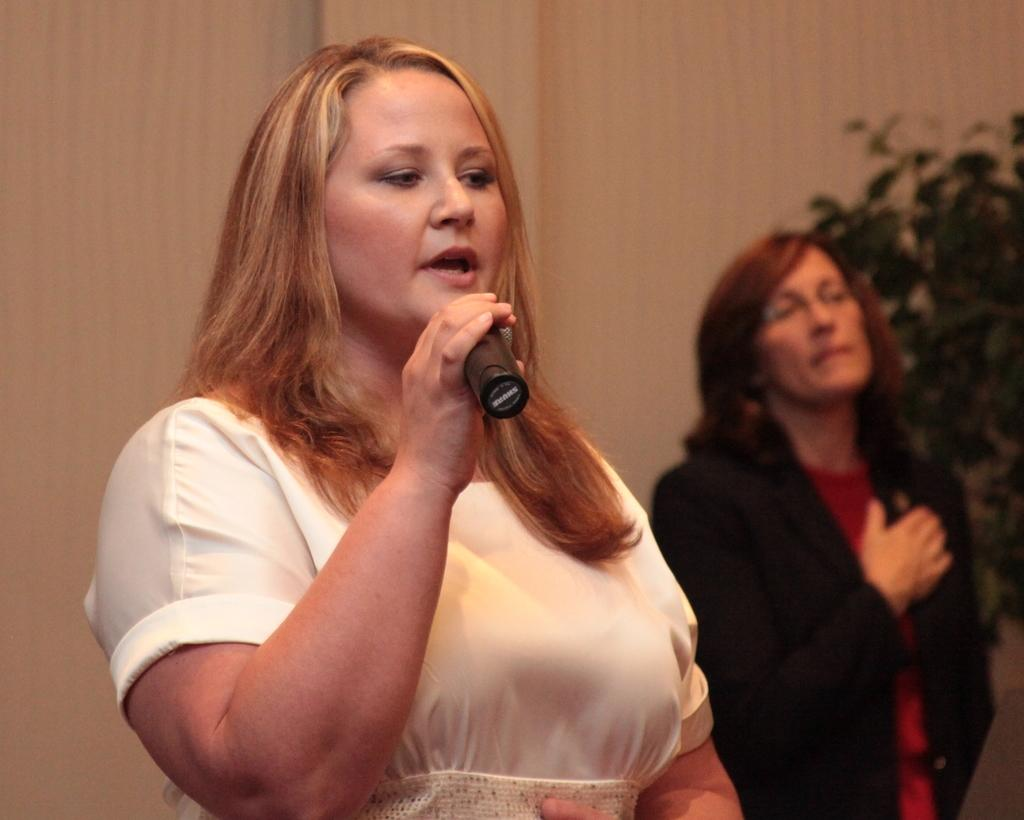What is the woman in the image holding? The woman is holding a mic in the image. What is the woman with the mic doing? The woman is talking. Can you describe the other woman in the image? There is another woman standing in the image. What type of vegetation can be seen in the image? There is a plant visible in the image. What is at the back of the scene? There is a wall at the back of the scene. What type of cream is being offered by the woman with the mic? There is no cream being offered in the image; the woman is holding a mic and talking. 